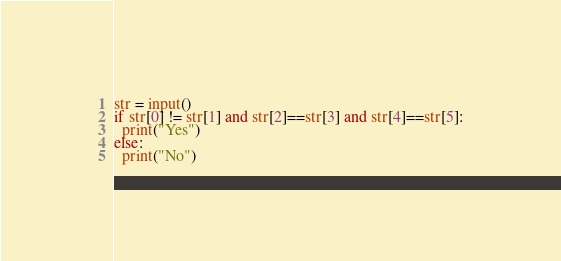<code> <loc_0><loc_0><loc_500><loc_500><_Python_>str = input()
if str[0] != str[1] and str[2]==str[3] and str[4]==str[5]:
  print("Yes")
else:
  print("No")</code> 